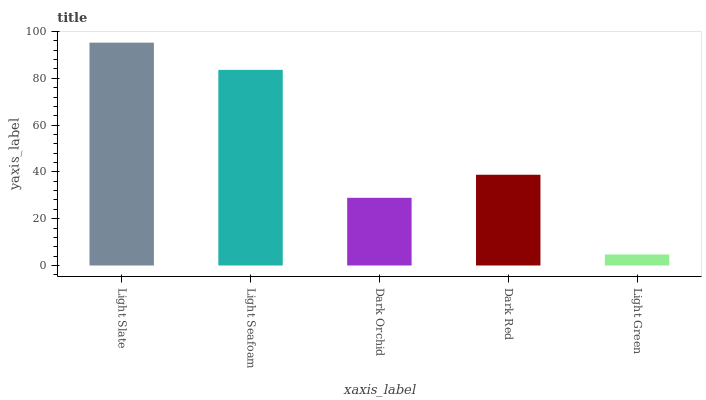Is Light Seafoam the minimum?
Answer yes or no. No. Is Light Seafoam the maximum?
Answer yes or no. No. Is Light Slate greater than Light Seafoam?
Answer yes or no. Yes. Is Light Seafoam less than Light Slate?
Answer yes or no. Yes. Is Light Seafoam greater than Light Slate?
Answer yes or no. No. Is Light Slate less than Light Seafoam?
Answer yes or no. No. Is Dark Red the high median?
Answer yes or no. Yes. Is Dark Red the low median?
Answer yes or no. Yes. Is Light Green the high median?
Answer yes or no. No. Is Light Seafoam the low median?
Answer yes or no. No. 